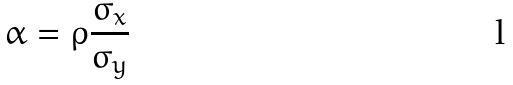Convert formula to latex. <formula><loc_0><loc_0><loc_500><loc_500>\alpha = \rho \frac { \sigma _ { x } } { \sigma _ { y } }</formula> 